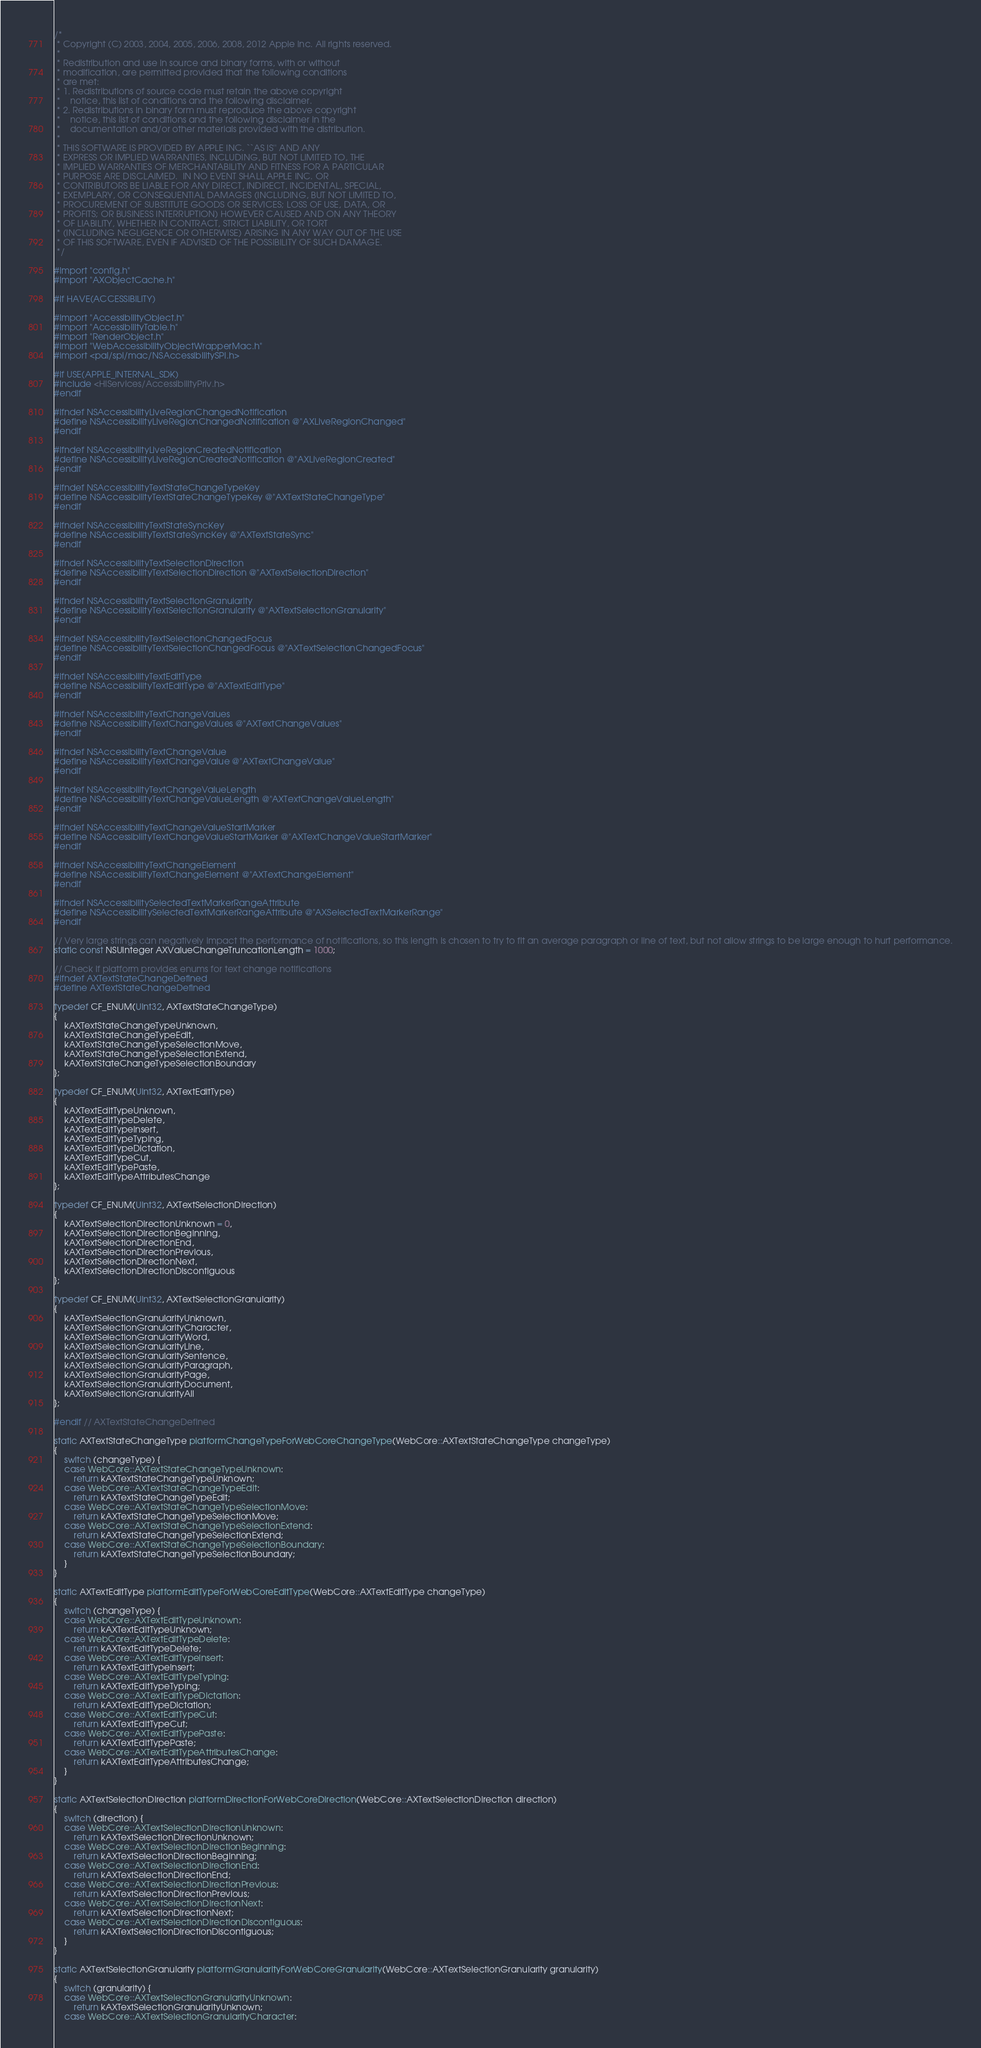<code> <loc_0><loc_0><loc_500><loc_500><_ObjectiveC_>/*
 * Copyright (C) 2003, 2004, 2005, 2006, 2008, 2012 Apple Inc. All rights reserved.
 *
 * Redistribution and use in source and binary forms, with or without
 * modification, are permitted provided that the following conditions
 * are met:
 * 1. Redistributions of source code must retain the above copyright
 *    notice, this list of conditions and the following disclaimer.
 * 2. Redistributions in binary form must reproduce the above copyright
 *    notice, this list of conditions and the following disclaimer in the
 *    documentation and/or other materials provided with the distribution.
 *
 * THIS SOFTWARE IS PROVIDED BY APPLE INC. ``AS IS'' AND ANY
 * EXPRESS OR IMPLIED WARRANTIES, INCLUDING, BUT NOT LIMITED TO, THE
 * IMPLIED WARRANTIES OF MERCHANTABILITY AND FITNESS FOR A PARTICULAR
 * PURPOSE ARE DISCLAIMED.  IN NO EVENT SHALL APPLE INC. OR
 * CONTRIBUTORS BE LIABLE FOR ANY DIRECT, INDIRECT, INCIDENTAL, SPECIAL,
 * EXEMPLARY, OR CONSEQUENTIAL DAMAGES (INCLUDING, BUT NOT LIMITED TO,
 * PROCUREMENT OF SUBSTITUTE GOODS OR SERVICES; LOSS OF USE, DATA, OR
 * PROFITS; OR BUSINESS INTERRUPTION) HOWEVER CAUSED AND ON ANY THEORY
 * OF LIABILITY, WHETHER IN CONTRACT, STRICT LIABILITY, OR TORT
 * (INCLUDING NEGLIGENCE OR OTHERWISE) ARISING IN ANY WAY OUT OF THE USE
 * OF THIS SOFTWARE, EVEN IF ADVISED OF THE POSSIBILITY OF SUCH DAMAGE.
 */

#import "config.h"
#import "AXObjectCache.h"

#if HAVE(ACCESSIBILITY)

#import "AccessibilityObject.h"
#import "AccessibilityTable.h"
#import "RenderObject.h"
#import "WebAccessibilityObjectWrapperMac.h"
#import <pal/spi/mac/NSAccessibilitySPI.h>

#if USE(APPLE_INTERNAL_SDK)
#include <HIServices/AccessibilityPriv.h>
#endif

#ifndef NSAccessibilityLiveRegionChangedNotification
#define NSAccessibilityLiveRegionChangedNotification @"AXLiveRegionChanged"
#endif

#ifndef NSAccessibilityLiveRegionCreatedNotification 
#define NSAccessibilityLiveRegionCreatedNotification @"AXLiveRegionCreated"
#endif

#ifndef NSAccessibilityTextStateChangeTypeKey
#define NSAccessibilityTextStateChangeTypeKey @"AXTextStateChangeType"
#endif

#ifndef NSAccessibilityTextStateSyncKey
#define NSAccessibilityTextStateSyncKey @"AXTextStateSync"
#endif

#ifndef NSAccessibilityTextSelectionDirection
#define NSAccessibilityTextSelectionDirection @"AXTextSelectionDirection"
#endif

#ifndef NSAccessibilityTextSelectionGranularity
#define NSAccessibilityTextSelectionGranularity @"AXTextSelectionGranularity"
#endif

#ifndef NSAccessibilityTextSelectionChangedFocus
#define NSAccessibilityTextSelectionChangedFocus @"AXTextSelectionChangedFocus"
#endif

#ifndef NSAccessibilityTextEditType
#define NSAccessibilityTextEditType @"AXTextEditType"
#endif

#ifndef NSAccessibilityTextChangeValues
#define NSAccessibilityTextChangeValues @"AXTextChangeValues"
#endif

#ifndef NSAccessibilityTextChangeValue
#define NSAccessibilityTextChangeValue @"AXTextChangeValue"
#endif

#ifndef NSAccessibilityTextChangeValueLength
#define NSAccessibilityTextChangeValueLength @"AXTextChangeValueLength"
#endif

#ifndef NSAccessibilityTextChangeValueStartMarker
#define NSAccessibilityTextChangeValueStartMarker @"AXTextChangeValueStartMarker"
#endif

#ifndef NSAccessibilityTextChangeElement
#define NSAccessibilityTextChangeElement @"AXTextChangeElement"
#endif

#ifndef NSAccessibilitySelectedTextMarkerRangeAttribute
#define NSAccessibilitySelectedTextMarkerRangeAttribute @"AXSelectedTextMarkerRange"
#endif

// Very large strings can negatively impact the performance of notifications, so this length is chosen to try to fit an average paragraph or line of text, but not allow strings to be large enough to hurt performance.
static const NSUInteger AXValueChangeTruncationLength = 1000;

// Check if platform provides enums for text change notifications
#ifndef AXTextStateChangeDefined
#define AXTextStateChangeDefined

typedef CF_ENUM(UInt32, AXTextStateChangeType)
{
    kAXTextStateChangeTypeUnknown,
    kAXTextStateChangeTypeEdit,
    kAXTextStateChangeTypeSelectionMove,
    kAXTextStateChangeTypeSelectionExtend,
    kAXTextStateChangeTypeSelectionBoundary
};

typedef CF_ENUM(UInt32, AXTextEditType)
{
    kAXTextEditTypeUnknown,
    kAXTextEditTypeDelete,
    kAXTextEditTypeInsert,
    kAXTextEditTypeTyping,
    kAXTextEditTypeDictation,
    kAXTextEditTypeCut,
    kAXTextEditTypePaste,
    kAXTextEditTypeAttributesChange
};

typedef CF_ENUM(UInt32, AXTextSelectionDirection)
{
    kAXTextSelectionDirectionUnknown = 0,
    kAXTextSelectionDirectionBeginning,
    kAXTextSelectionDirectionEnd,
    kAXTextSelectionDirectionPrevious,
    kAXTextSelectionDirectionNext,
    kAXTextSelectionDirectionDiscontiguous
};

typedef CF_ENUM(UInt32, AXTextSelectionGranularity)
{
    kAXTextSelectionGranularityUnknown,
    kAXTextSelectionGranularityCharacter,
    kAXTextSelectionGranularityWord,
    kAXTextSelectionGranularityLine,
    kAXTextSelectionGranularitySentence,
    kAXTextSelectionGranularityParagraph,
    kAXTextSelectionGranularityPage,
    kAXTextSelectionGranularityDocument,
    kAXTextSelectionGranularityAll
};

#endif // AXTextStateChangeDefined

static AXTextStateChangeType platformChangeTypeForWebCoreChangeType(WebCore::AXTextStateChangeType changeType)
{
    switch (changeType) {
    case WebCore::AXTextStateChangeTypeUnknown:
        return kAXTextStateChangeTypeUnknown;
    case WebCore::AXTextStateChangeTypeEdit:
        return kAXTextStateChangeTypeEdit;
    case WebCore::AXTextStateChangeTypeSelectionMove:
        return kAXTextStateChangeTypeSelectionMove;
    case WebCore::AXTextStateChangeTypeSelectionExtend:
        return kAXTextStateChangeTypeSelectionExtend;
    case WebCore::AXTextStateChangeTypeSelectionBoundary:
        return kAXTextStateChangeTypeSelectionBoundary;
    }
}

static AXTextEditType platformEditTypeForWebCoreEditType(WebCore::AXTextEditType changeType)
{
    switch (changeType) {
    case WebCore::AXTextEditTypeUnknown:
        return kAXTextEditTypeUnknown;
    case WebCore::AXTextEditTypeDelete:
        return kAXTextEditTypeDelete;
    case WebCore::AXTextEditTypeInsert:
        return kAXTextEditTypeInsert;
    case WebCore::AXTextEditTypeTyping:
        return kAXTextEditTypeTyping;
    case WebCore::AXTextEditTypeDictation:
        return kAXTextEditTypeDictation;
    case WebCore::AXTextEditTypeCut:
        return kAXTextEditTypeCut;
    case WebCore::AXTextEditTypePaste:
        return kAXTextEditTypePaste;
    case WebCore::AXTextEditTypeAttributesChange:
        return kAXTextEditTypeAttributesChange;
    }
}

static AXTextSelectionDirection platformDirectionForWebCoreDirection(WebCore::AXTextSelectionDirection direction)
{
    switch (direction) {
    case WebCore::AXTextSelectionDirectionUnknown:
        return kAXTextSelectionDirectionUnknown;
    case WebCore::AXTextSelectionDirectionBeginning:
        return kAXTextSelectionDirectionBeginning;
    case WebCore::AXTextSelectionDirectionEnd:
        return kAXTextSelectionDirectionEnd;
    case WebCore::AXTextSelectionDirectionPrevious:
        return kAXTextSelectionDirectionPrevious;
    case WebCore::AXTextSelectionDirectionNext:
        return kAXTextSelectionDirectionNext;
    case WebCore::AXTextSelectionDirectionDiscontiguous:
        return kAXTextSelectionDirectionDiscontiguous;
    }
}

static AXTextSelectionGranularity platformGranularityForWebCoreGranularity(WebCore::AXTextSelectionGranularity granularity)
{
    switch (granularity) {
    case WebCore::AXTextSelectionGranularityUnknown:
        return kAXTextSelectionGranularityUnknown;
    case WebCore::AXTextSelectionGranularityCharacter:</code> 